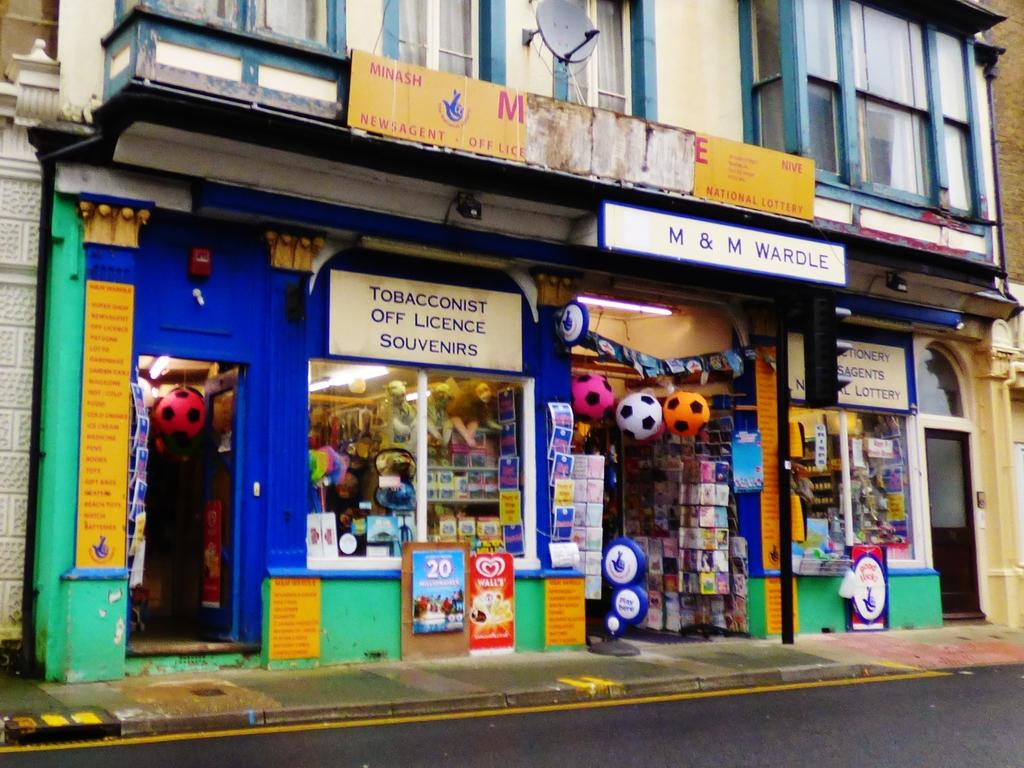<image>
Describe the image concisely. A storefront with the sign reading Tobacconist Off Licence Souvenirs 